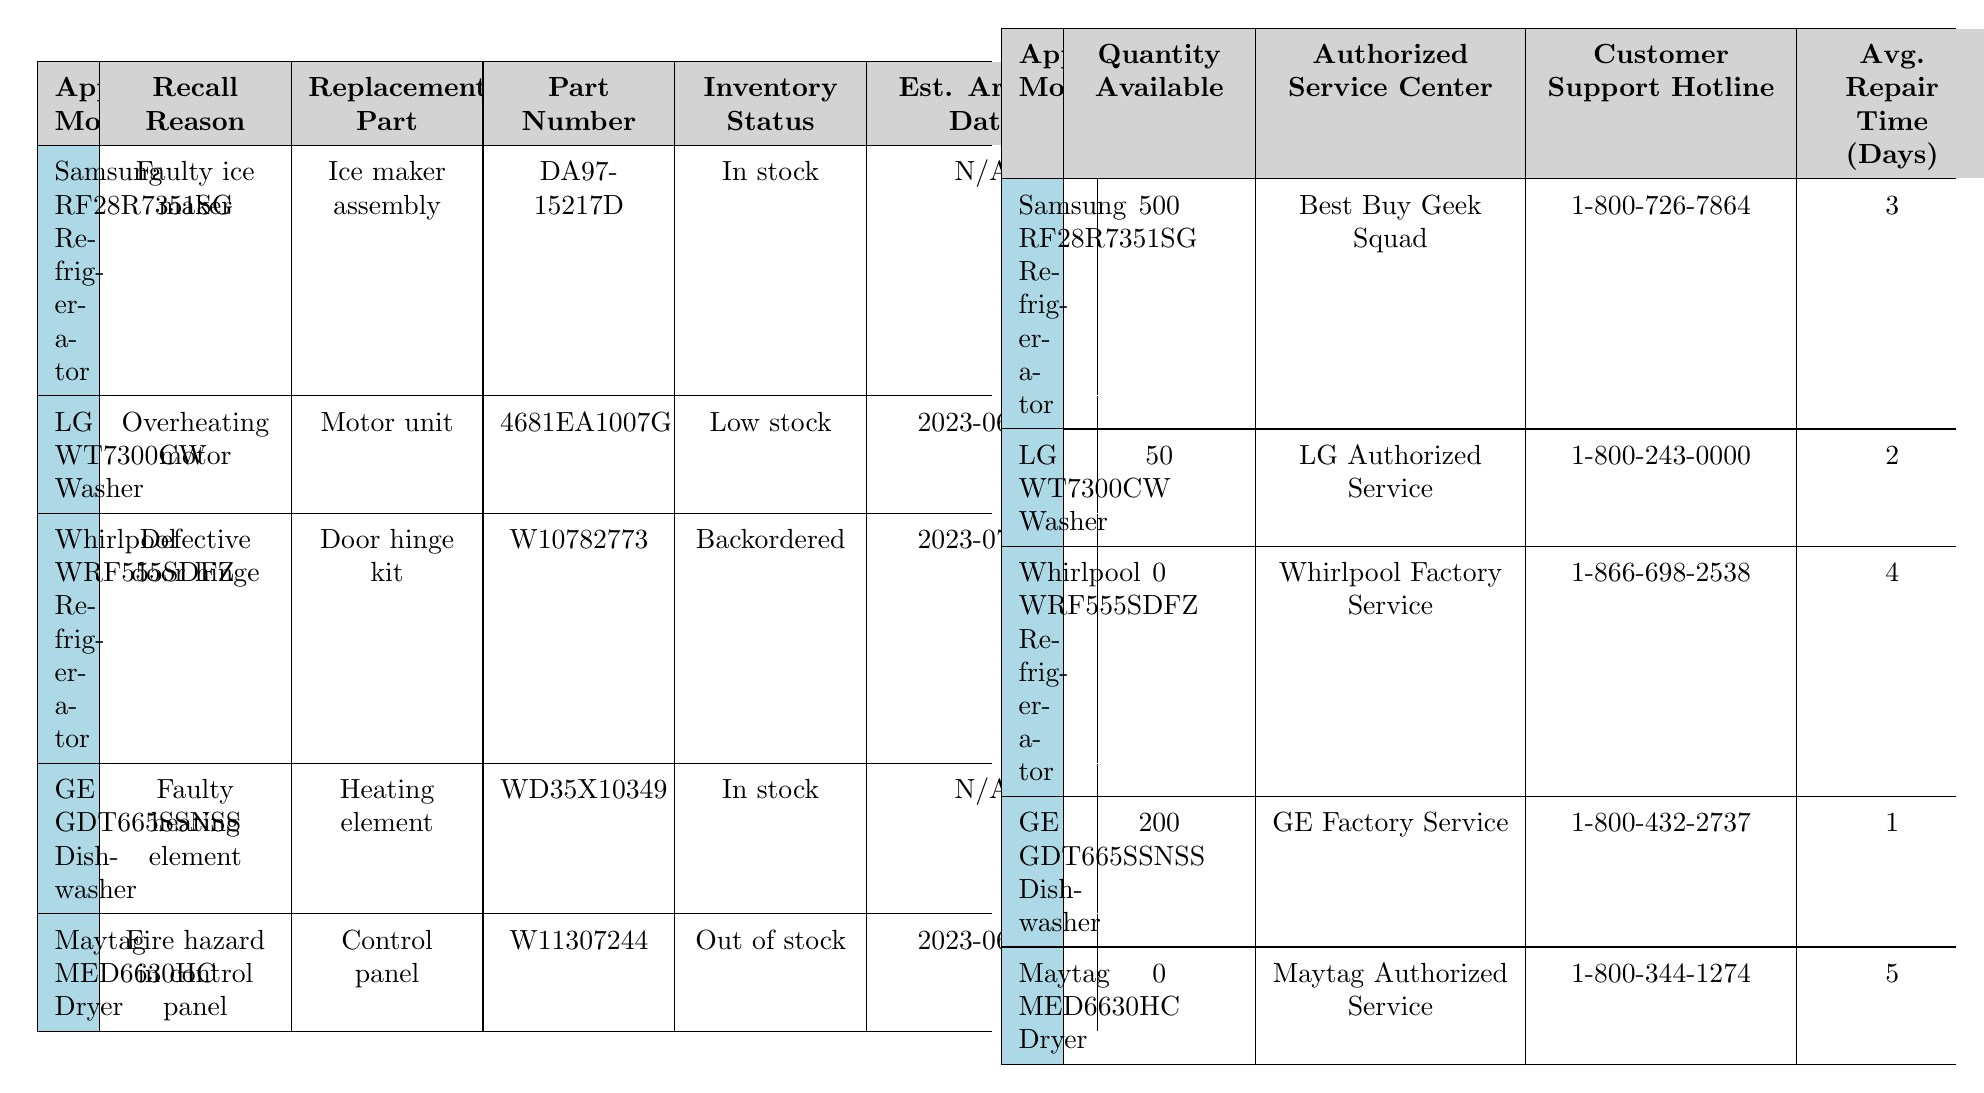What is the inventory status of the "Maytag MED6630HC Dryer"? According to the table, the inventory status of the Maytag MED6630HC Dryer is listed as "Out of stock."
Answer: Out of stock How many units are available for the "Samsung RF28R7351SG Refrigerator"? The quantity available for the Samsung RF28R7351SG Refrigerator is 500 units as indicated in the table.
Answer: 500 Which appliance has a replacement part that is backordered? The Whirlpool WRF555SDFZ Refrigerator has its replacement part listed as backordered.
Answer: Whirlpool WRF555SDFZ Refrigerator What is the estimated arrival date for the "LG WT7300CW Washer" replacement part? The estimated arrival date for the LG WT7300CW Washer's replacement part is shown as June 15, 2023.
Answer: 2023-06-15 Is there a customer support hotline for the "GE GDT665SSNSS Dishwasher"? Yes, the GE GDT665SSNSS Dishwasher is associated with a customer support hotline, which is 1-800-432-2737.
Answer: Yes What is the average repair time for the "GE GDT665SSNSS Dishwasher"? The average repair time for the GE GDT665SSNSS Dishwasher is stated as 1 day in the table.
Answer: 1 day Which appliance has the longest average repair time? The appliance with the longest average repair time is the Maytag MED6630HC Dryer, which takes 5 days to repair.
Answer: Maytag MED6630HC Dryer What is the total number of replacement parts available for appliances that are currently in stock? Two appliances - the Samsung RF28R7351SG Refrigerator and the GE GDT665SSNSS Dishwasher - have replacement parts in stock, totaling 700 units (500 + 200).
Answer: 700 What is the part number for the "Door hinge kit"? The part number for the Door hinge kit is W10782773 as per the table.
Answer: W10782773 Which replacement part has the earliest estimated arrival date? The Motor unit for the LG WT7300CW Washer has the earliest estimated arrival date of June 15, 2023.
Answer: Motor unit What is the percentage of appliances that are out of stock? There are 5 appliances listed, and 2 of them (Whirlpool WRF555SDFZ Refrigerator and Maytag MED6630HC Dryer) are out of stock, which is 40% of the total.
Answer: 40% If the inventory status of "LG WT7300CW Washer" changes to in stock, how many total parts would then be in stock? Currently, there are 500 (Samsung) + 200 (GE) + 50 (LG) = 750 parts in stock. If the LG WT7300CW Washer changes to in stock, it adds 50 more, totaling 800 parts.
Answer: 800 